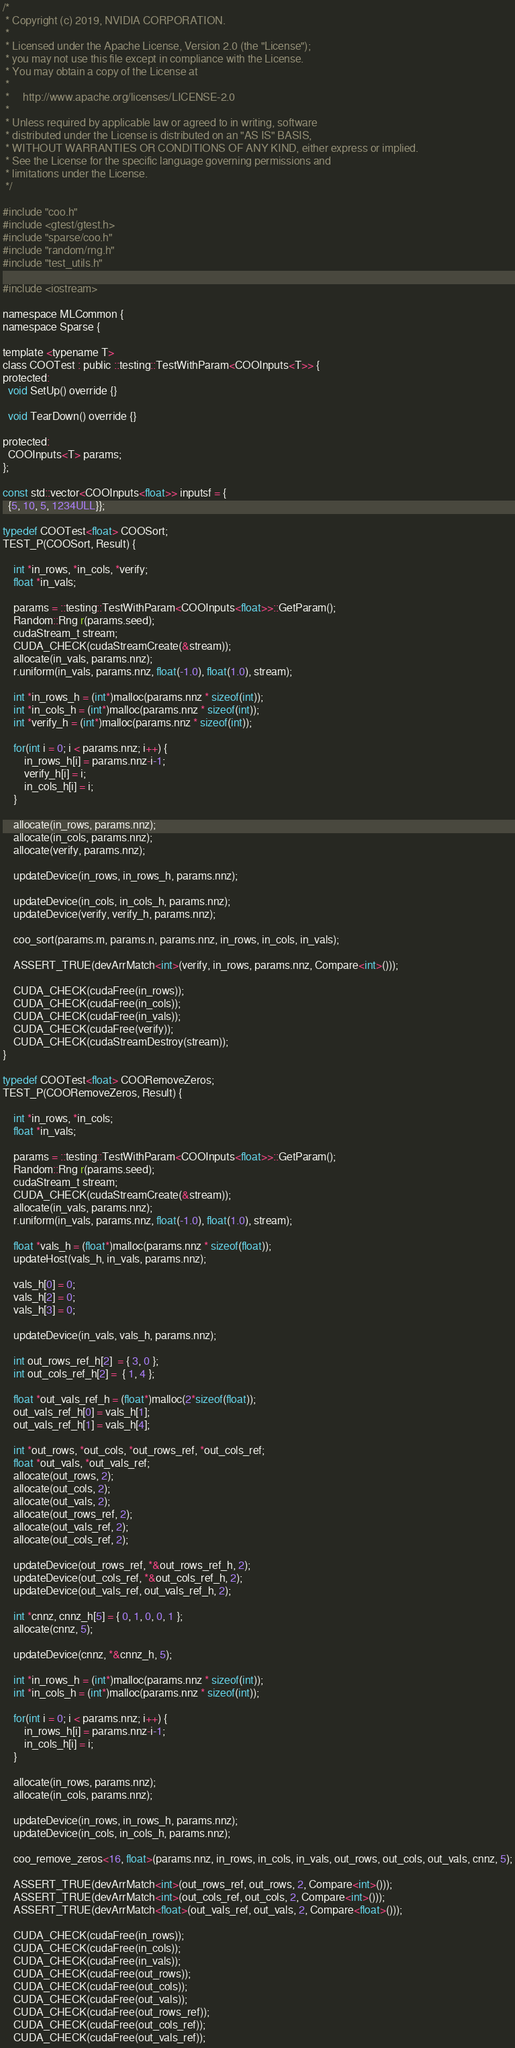Convert code to text. <code><loc_0><loc_0><loc_500><loc_500><_Cuda_>/*
 * Copyright (c) 2019, NVIDIA CORPORATION.
 *
 * Licensed under the Apache License, Version 2.0 (the "License");
 * you may not use this file except in compliance with the License.
 * You may obtain a copy of the License at
 *
 *     http://www.apache.org/licenses/LICENSE-2.0
 *
 * Unless required by applicable law or agreed to in writing, software
 * distributed under the License is distributed on an "AS IS" BASIS,
 * WITHOUT WARRANTIES OR CONDITIONS OF ANY KIND, either express or implied.
 * See the License for the specific language governing permissions and
 * limitations under the License.
 */

#include "coo.h"
#include <gtest/gtest.h>
#include "sparse/coo.h"
#include "random/rng.h"
#include "test_utils.h"

#include <iostream>

namespace MLCommon {
namespace Sparse {

template <typename T>
class COOTest : public ::testing::TestWithParam<COOInputs<T>> {
protected:
  void SetUp() override {}

  void TearDown() override {}

protected:
  COOInputs<T> params;
};

const std::vector<COOInputs<float>> inputsf = {
  {5, 10, 5, 1234ULL}};

typedef COOTest<float> COOSort;
TEST_P(COOSort, Result) {

    int *in_rows, *in_cols, *verify;
    float *in_vals;

    params = ::testing::TestWithParam<COOInputs<float>>::GetParam();
    Random::Rng r(params.seed);
    cudaStream_t stream;
    CUDA_CHECK(cudaStreamCreate(&stream));
    allocate(in_vals, params.nnz);
    r.uniform(in_vals, params.nnz, float(-1.0), float(1.0), stream);

    int *in_rows_h = (int*)malloc(params.nnz * sizeof(int));
    int *in_cols_h = (int*)malloc(params.nnz * sizeof(int));
    int *verify_h = (int*)malloc(params.nnz * sizeof(int));

    for(int i = 0; i < params.nnz; i++) {
        in_rows_h[i] = params.nnz-i-1;
        verify_h[i] = i;
        in_cols_h[i] = i;
    }

    allocate(in_rows, params.nnz);
    allocate(in_cols, params.nnz);
    allocate(verify, params.nnz);

    updateDevice(in_rows, in_rows_h, params.nnz);

    updateDevice(in_cols, in_cols_h, params.nnz);
    updateDevice(verify, verify_h, params.nnz);

    coo_sort(params.m, params.n, params.nnz, in_rows, in_cols, in_vals);

    ASSERT_TRUE(devArrMatch<int>(verify, in_rows, params.nnz, Compare<int>()));

    CUDA_CHECK(cudaFree(in_rows));
    CUDA_CHECK(cudaFree(in_cols));
    CUDA_CHECK(cudaFree(in_vals));
    CUDA_CHECK(cudaFree(verify));
    CUDA_CHECK(cudaStreamDestroy(stream));
}

typedef COOTest<float> COORemoveZeros;
TEST_P(COORemoveZeros, Result) {

    int *in_rows, *in_cols;
    float *in_vals;

    params = ::testing::TestWithParam<COOInputs<float>>::GetParam();
    Random::Rng r(params.seed);
    cudaStream_t stream;
    CUDA_CHECK(cudaStreamCreate(&stream));
    allocate(in_vals, params.nnz);
    r.uniform(in_vals, params.nnz, float(-1.0), float(1.0), stream);

    float *vals_h = (float*)malloc(params.nnz * sizeof(float));
    updateHost(vals_h, in_vals, params.nnz);

    vals_h[0] = 0;
    vals_h[2] = 0;
    vals_h[3] = 0;

    updateDevice(in_vals, vals_h, params.nnz);

    int out_rows_ref_h[2]  = { 3, 0 };
    int out_cols_ref_h[2] =  { 1, 4 };

    float *out_vals_ref_h = (float*)malloc(2*sizeof(float));
    out_vals_ref_h[0] = vals_h[1];
    out_vals_ref_h[1] = vals_h[4];

    int *out_rows, *out_cols, *out_rows_ref, *out_cols_ref;
    float *out_vals, *out_vals_ref;
    allocate(out_rows, 2);
    allocate(out_cols, 2);
    allocate(out_vals, 2);
    allocate(out_rows_ref, 2);
    allocate(out_vals_ref, 2);
    allocate(out_cols_ref, 2);

    updateDevice(out_rows_ref, *&out_rows_ref_h, 2);
    updateDevice(out_cols_ref, *&out_cols_ref_h, 2);
    updateDevice(out_vals_ref, out_vals_ref_h, 2);

    int *cnnz, cnnz_h[5] = { 0, 1, 0, 0, 1 };
    allocate(cnnz, 5);

    updateDevice(cnnz, *&cnnz_h, 5);

    int *in_rows_h = (int*)malloc(params.nnz * sizeof(int));
    int *in_cols_h = (int*)malloc(params.nnz * sizeof(int));

    for(int i = 0; i < params.nnz; i++) {
        in_rows_h[i] = params.nnz-i-1;
        in_cols_h[i] = i;
    }

    allocate(in_rows, params.nnz);
    allocate(in_cols, params.nnz);

    updateDevice(in_rows, in_rows_h, params.nnz);
    updateDevice(in_cols, in_cols_h, params.nnz);

    coo_remove_zeros<16, float>(params.nnz, in_rows, in_cols, in_vals, out_rows, out_cols, out_vals, cnnz, 5);

    ASSERT_TRUE(devArrMatch<int>(out_rows_ref, out_rows, 2, Compare<int>()));
    ASSERT_TRUE(devArrMatch<int>(out_cols_ref, out_cols, 2, Compare<int>()));
    ASSERT_TRUE(devArrMatch<float>(out_vals_ref, out_vals, 2, Compare<float>()));

    CUDA_CHECK(cudaFree(in_rows));
    CUDA_CHECK(cudaFree(in_cols));
    CUDA_CHECK(cudaFree(in_vals));
    CUDA_CHECK(cudaFree(out_rows));
    CUDA_CHECK(cudaFree(out_cols));
    CUDA_CHECK(cudaFree(out_vals));
    CUDA_CHECK(cudaFree(out_rows_ref));
    CUDA_CHECK(cudaFree(out_cols_ref));
    CUDA_CHECK(cudaFree(out_vals_ref));</code> 